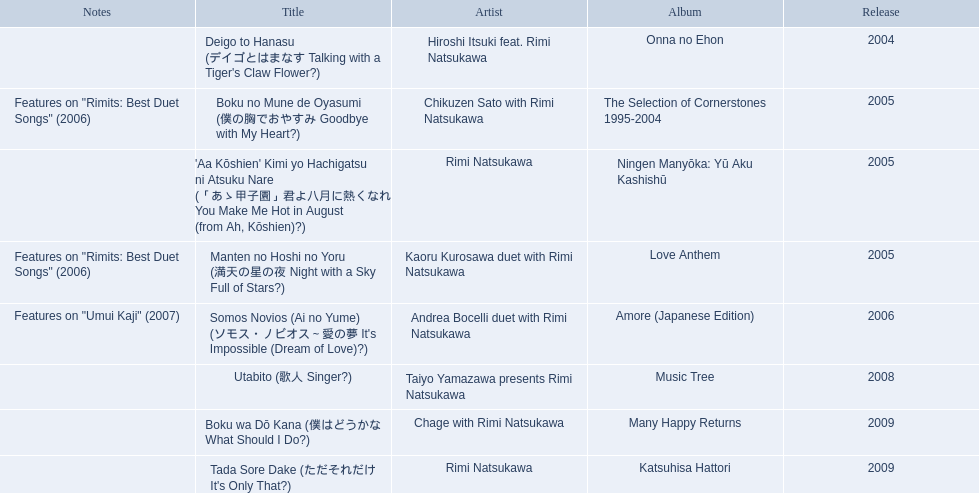What are all of the titles? Deigo to Hanasu (デイゴとはまなす Talking with a Tiger's Claw Flower?), Boku no Mune de Oyasumi (僕の胸でおやすみ Goodbye with My Heart?), 'Aa Kōshien' Kimi yo Hachigatsu ni Atsuku Nare (「あゝ甲子園」君よ八月に熱くなれ You Make Me Hot in August (from Ah, Kōshien)?), Manten no Hoshi no Yoru (満天の星の夜 Night with a Sky Full of Stars?), Somos Novios (Ai no Yume) (ソモス・ノビオス～愛の夢 It's Impossible (Dream of Love)?), Utabito (歌人 Singer?), Boku wa Dō Kana (僕はどうかな What Should I Do?), Tada Sore Dake (ただそれだけ It's Only That?). What are their notes? , Features on "Rimits: Best Duet Songs" (2006), , Features on "Rimits: Best Duet Songs" (2006), Features on "Umui Kaji" (2007), , , . Which title shares its notes with manten no hoshi no yoru (man tian noxing noye night with a sky full of stars?)? Boku no Mune de Oyasumi (僕の胸でおやすみ Goodbye with My Heart?). 